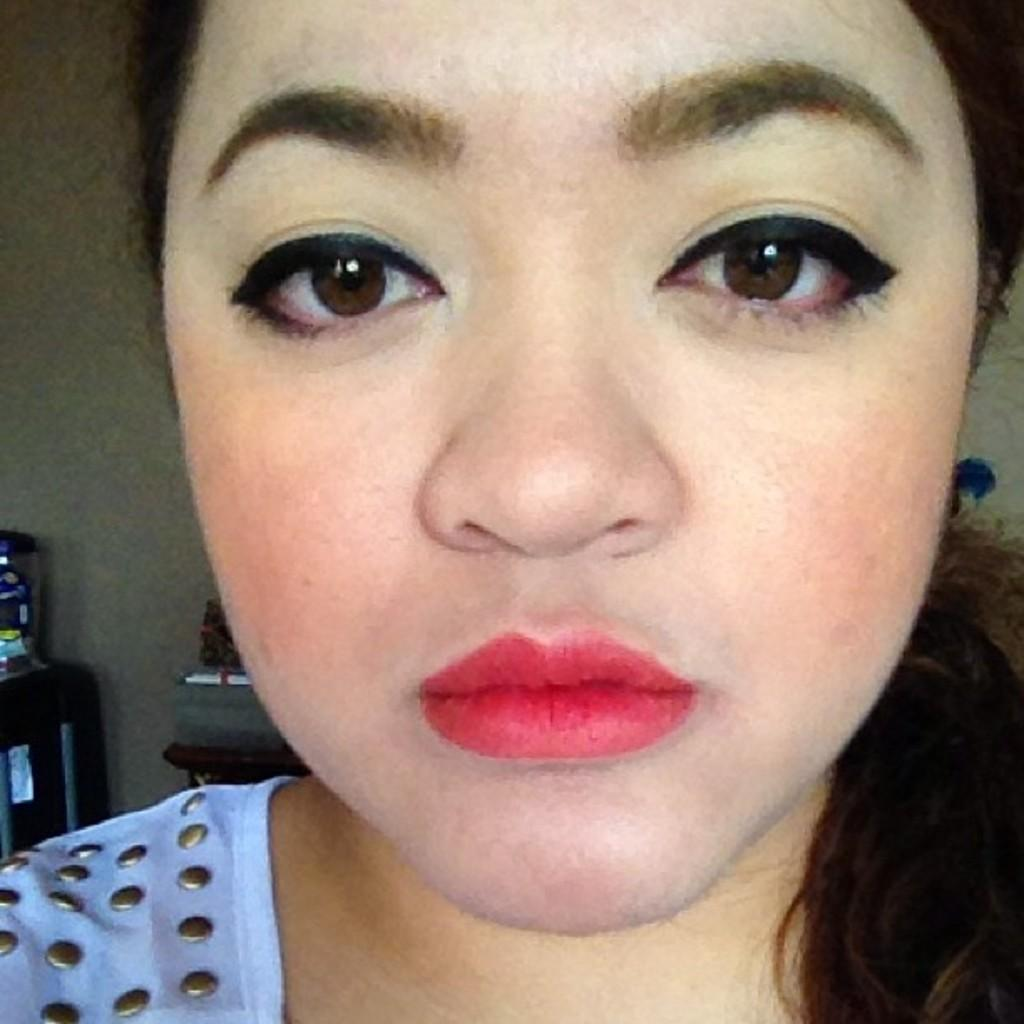Who is the main subject in the foreground of the image? There is a woman in the foreground of the image. What can be seen in the background of the image? There is a wall in the background of the image, along with some objects. What type of engine can be seen in the image? There is no engine present in the image. Is the sand visible in the image? There is no sand visible in the image. 